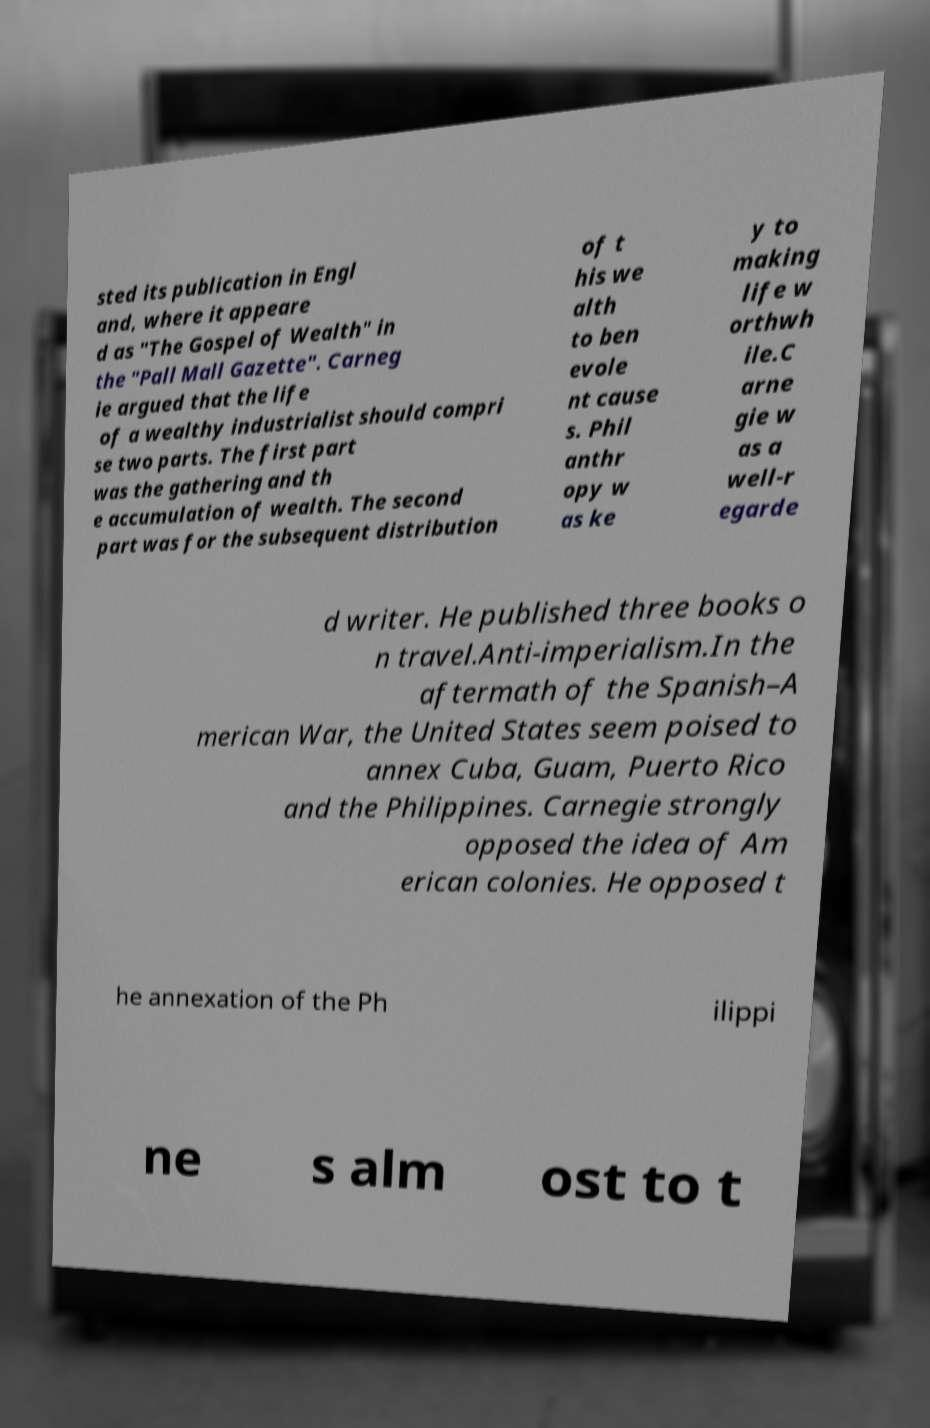Please read and relay the text visible in this image. What does it say? sted its publication in Engl and, where it appeare d as "The Gospel of Wealth" in the "Pall Mall Gazette". Carneg ie argued that the life of a wealthy industrialist should compri se two parts. The first part was the gathering and th e accumulation of wealth. The second part was for the subsequent distribution of t his we alth to ben evole nt cause s. Phil anthr opy w as ke y to making life w orthwh ile.C arne gie w as a well-r egarde d writer. He published three books o n travel.Anti-imperialism.In the aftermath of the Spanish–A merican War, the United States seem poised to annex Cuba, Guam, Puerto Rico and the Philippines. Carnegie strongly opposed the idea of Am erican colonies. He opposed t he annexation of the Ph ilippi ne s alm ost to t 